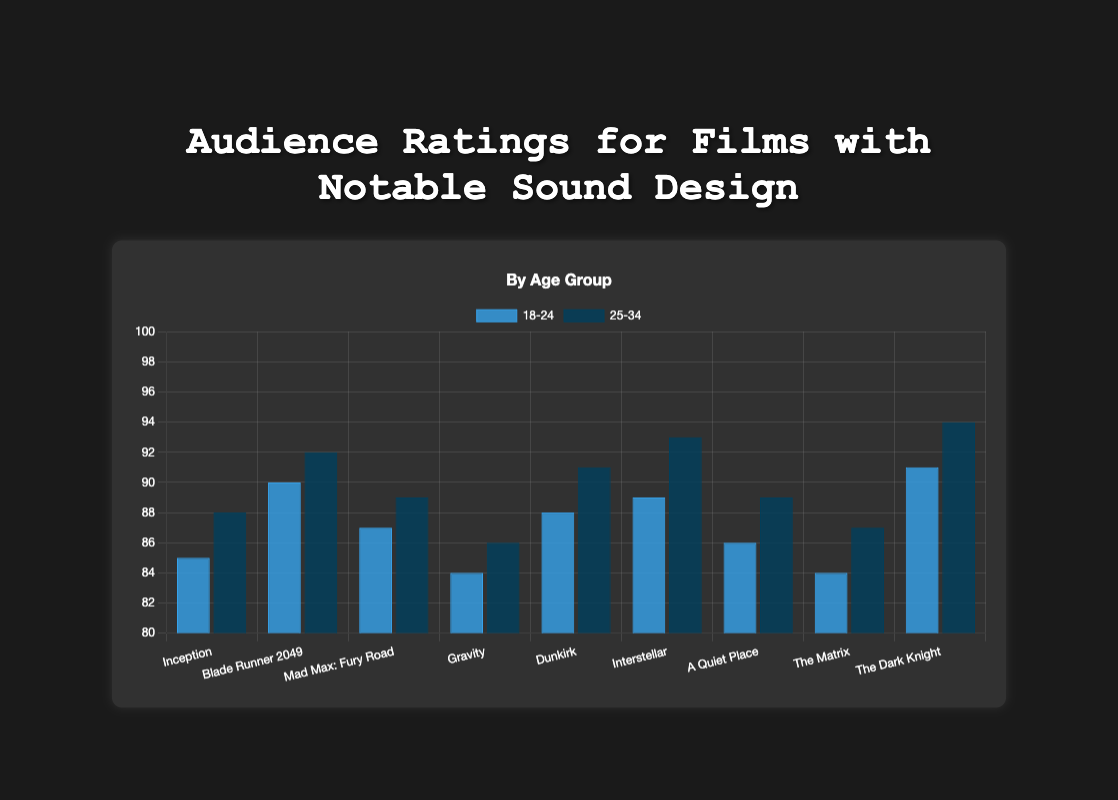Which age group rated "Interstellar" higher? The "Interstellar" bars show two ratings: 89 for the 18-24 age group and 93 for the 25-34 age group. Comparing these values, 93 (for 25-34) is higher than 89 (for 18-24).
Answer: 25-34 Which film has the lowest rating for the 18-24 age group? By observing the bar heights for the 18-24 age group, we see that "Gravity" and "The Matrix" both have the lowest ratings of 84.
Answer: Gravity and The Matrix How much higher is the rating for "Blade Runner 2049" by the 25-34 age group compared to the 18-24 age group? The rating for the 18-24 age group is 90 and for the 25-34 age group is 92. The difference is calculated as 92 - 90 = 2.
Answer: 2 What's the average rating of "Mad Max: Fury Road" across both age groups? The ratings for "Mad Max: Fury Road" are 87 for the 18-24 age group and 89 for the 25-34 age group. The average is calculated as (87 + 89) / 2 = 88.
Answer: 88 If you look at the rating trends, which film shows the largest rating increase from the 18-24 age group to the 25-34 age group? Comparing the increase, "Inception" (88 - 85 = 3), "Blade Runner 2049" (92 - 90 = 2), "Mad Max: Fury Road" (89 - 87 = 2), "Gravity" (86 - 84 = 2), "Dunkirk" (91 - 88 = 3), "Interstellar" (93 - 89 = 4), "A Quiet Place" (89 - 86 = 3), "The Matrix" (87 - 84 = 3), "The Dark Knight" (94 - 91 = 3). The largest increase is for "Interstellar" with 4 points.
Answer: Interstellar Which film received the highest rating overall, combining both age groups? Observing both age groups, "The Dark Knight" has the highest ratings with 94 (25-34) and 91 (18-24).
Answer: The Dark Knight Which age group generally rates the films higher? Comparing the averages of each age group's ratings, we see that the bars for the 25-34 age group are generally higher than those for the 18-24 age group.
Answer: 25-34 